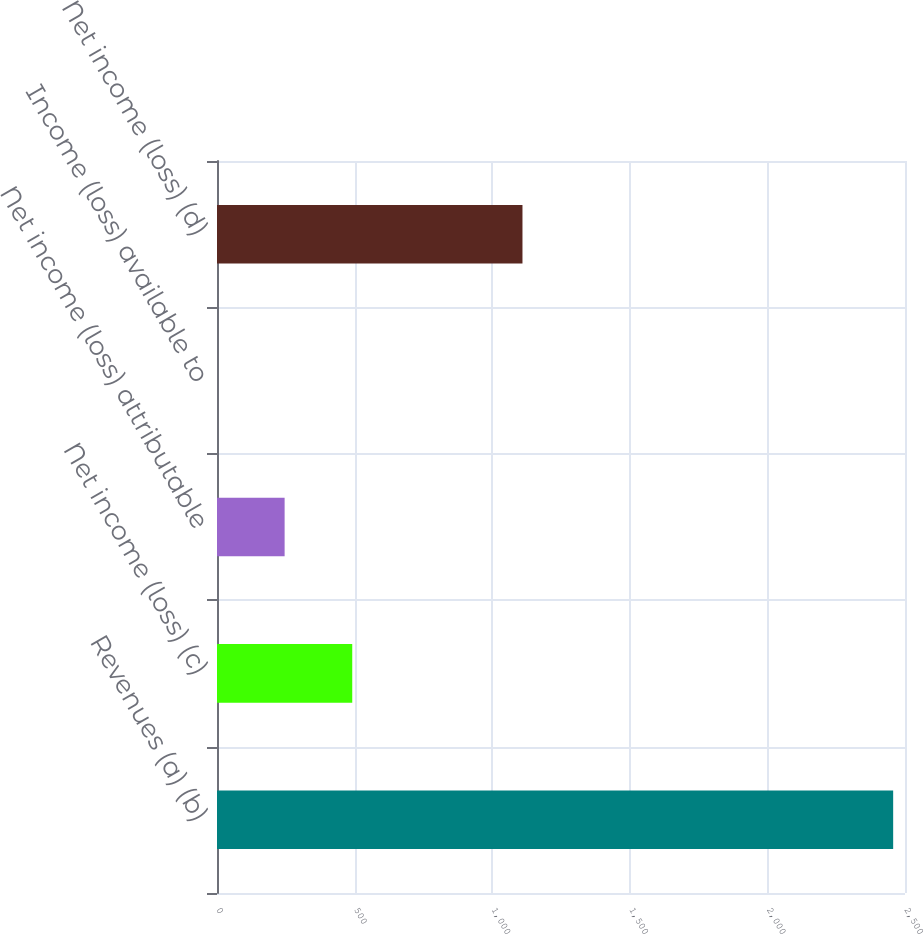<chart> <loc_0><loc_0><loc_500><loc_500><bar_chart><fcel>Revenues (a) (b)<fcel>Net income (loss) (c)<fcel>Net income (loss) attributable<fcel>Income (loss) available to<fcel>Net income (loss) (d)<nl><fcel>2457<fcel>491.42<fcel>245.72<fcel>0.02<fcel>1110<nl></chart> 